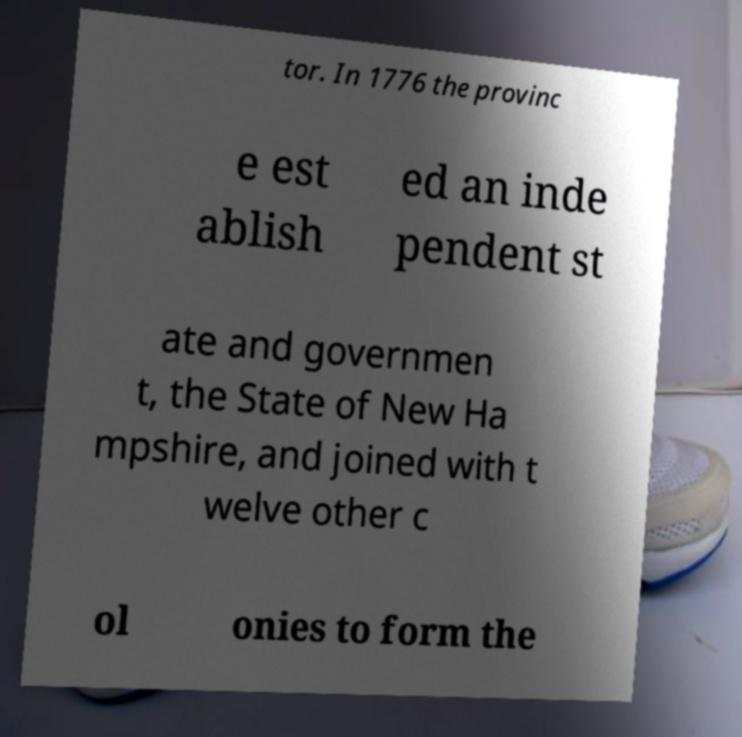There's text embedded in this image that I need extracted. Can you transcribe it verbatim? tor. In 1776 the provinc e est ablish ed an inde pendent st ate and governmen t, the State of New Ha mpshire, and joined with t welve other c ol onies to form the 